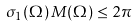Convert formula to latex. <formula><loc_0><loc_0><loc_500><loc_500>\sigma _ { 1 } ( \Omega ) \, M ( \Omega ) \leq 2 \pi</formula> 